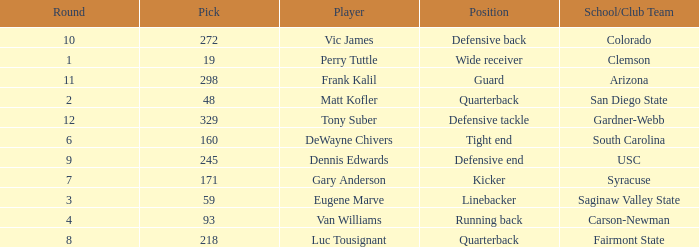Which Round has a School/Club Team of arizona, and a Pick smaller than 298? None. 